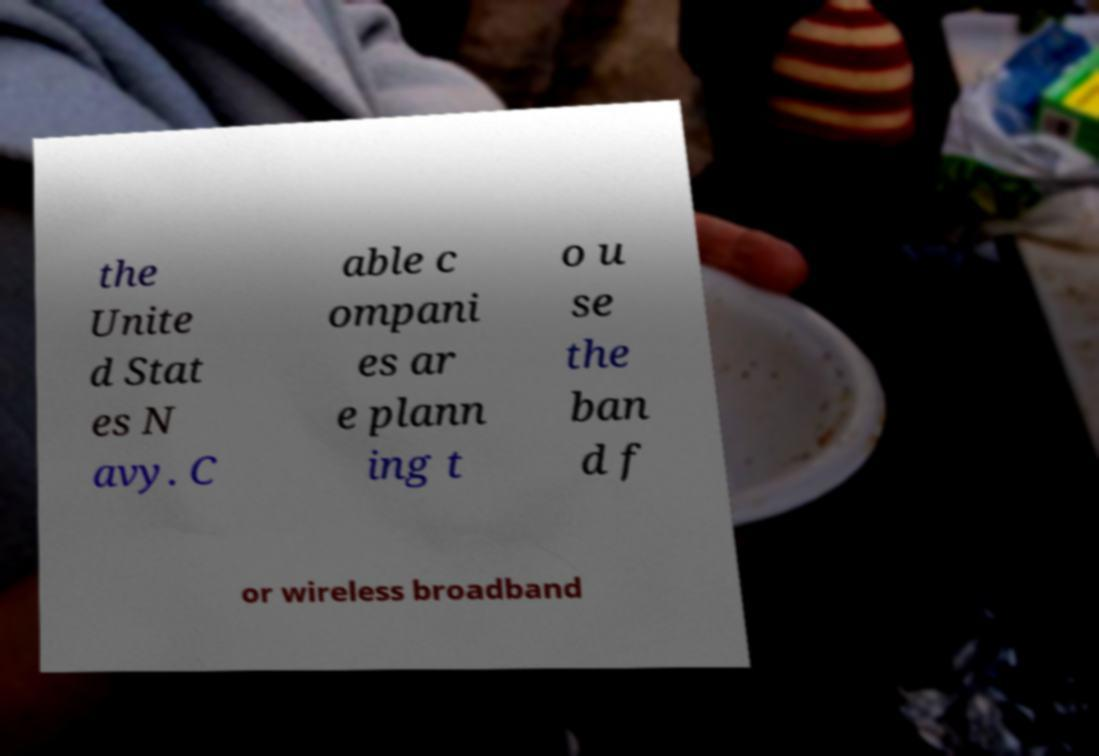I need the written content from this picture converted into text. Can you do that? the Unite d Stat es N avy. C able c ompani es ar e plann ing t o u se the ban d f or wireless broadband 